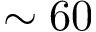<formula> <loc_0><loc_0><loc_500><loc_500>\sim 6 0</formula> 